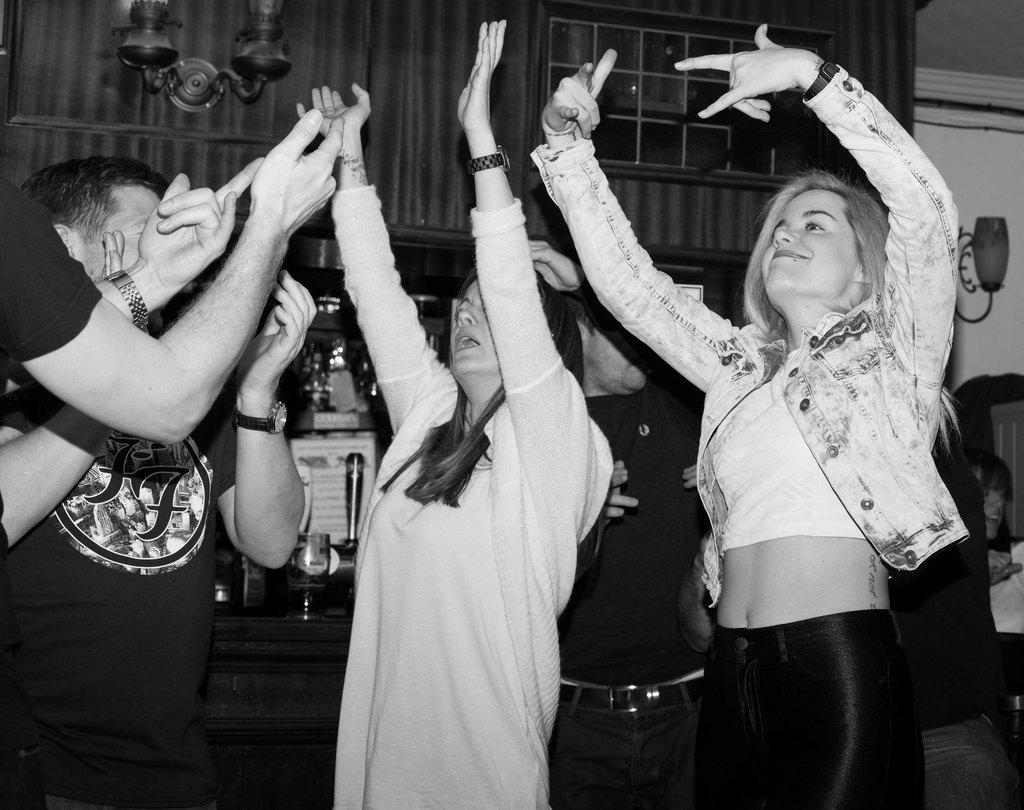What is the color scheme of the image? The image is black and white. What are the people in the image doing? The people are dancing in the image. What can be seen behind the people in the image? There are objects visible behind the people in the image. What is present in the background of the image? There is a wall in the background of the image. What type of lettuce is being used as a prop by the dancers in the image? There is no lettuce present in the image, and the people are not using any props while dancing. 